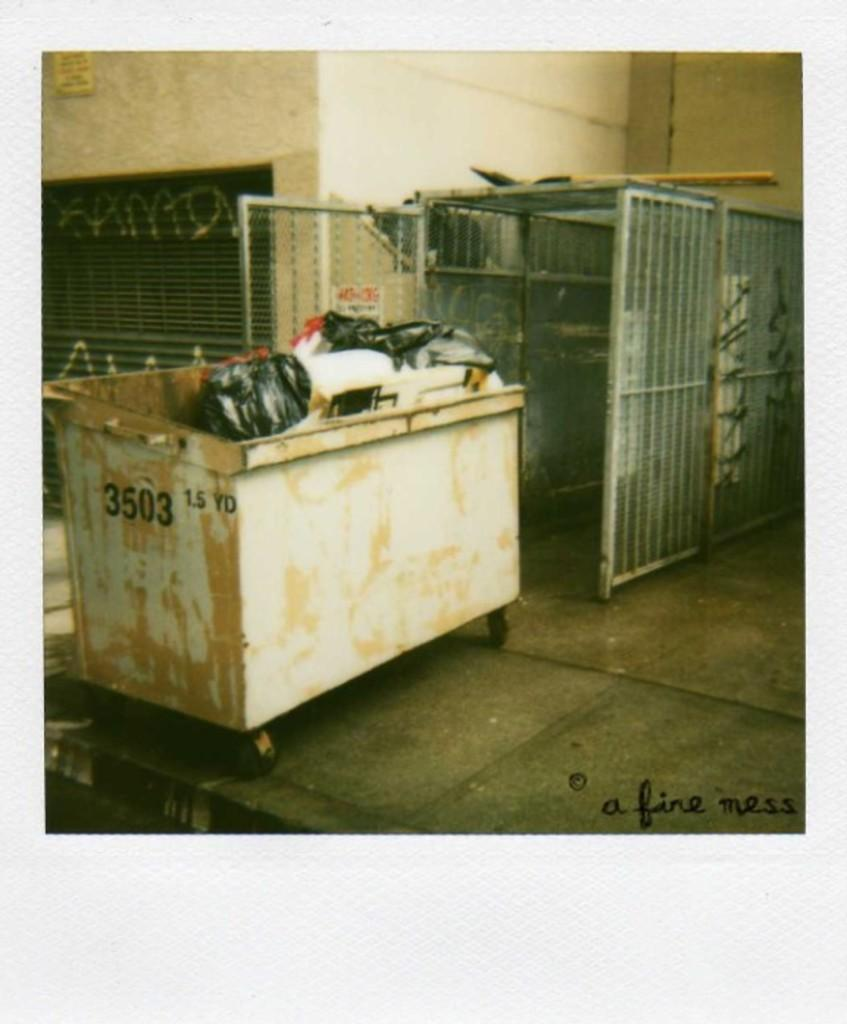<image>
Relay a brief, clear account of the picture shown. a white dumpster number 3503 outside an industrial cage 